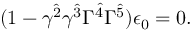Convert formula to latex. <formula><loc_0><loc_0><loc_500><loc_500>( 1 - \gamma ^ { \hat { 2 } } \gamma ^ { \hat { 3 } } \Gamma ^ { \hat { 4 } } \Gamma ^ { \hat { 5 } } ) \epsilon _ { 0 } = 0 .</formula> 